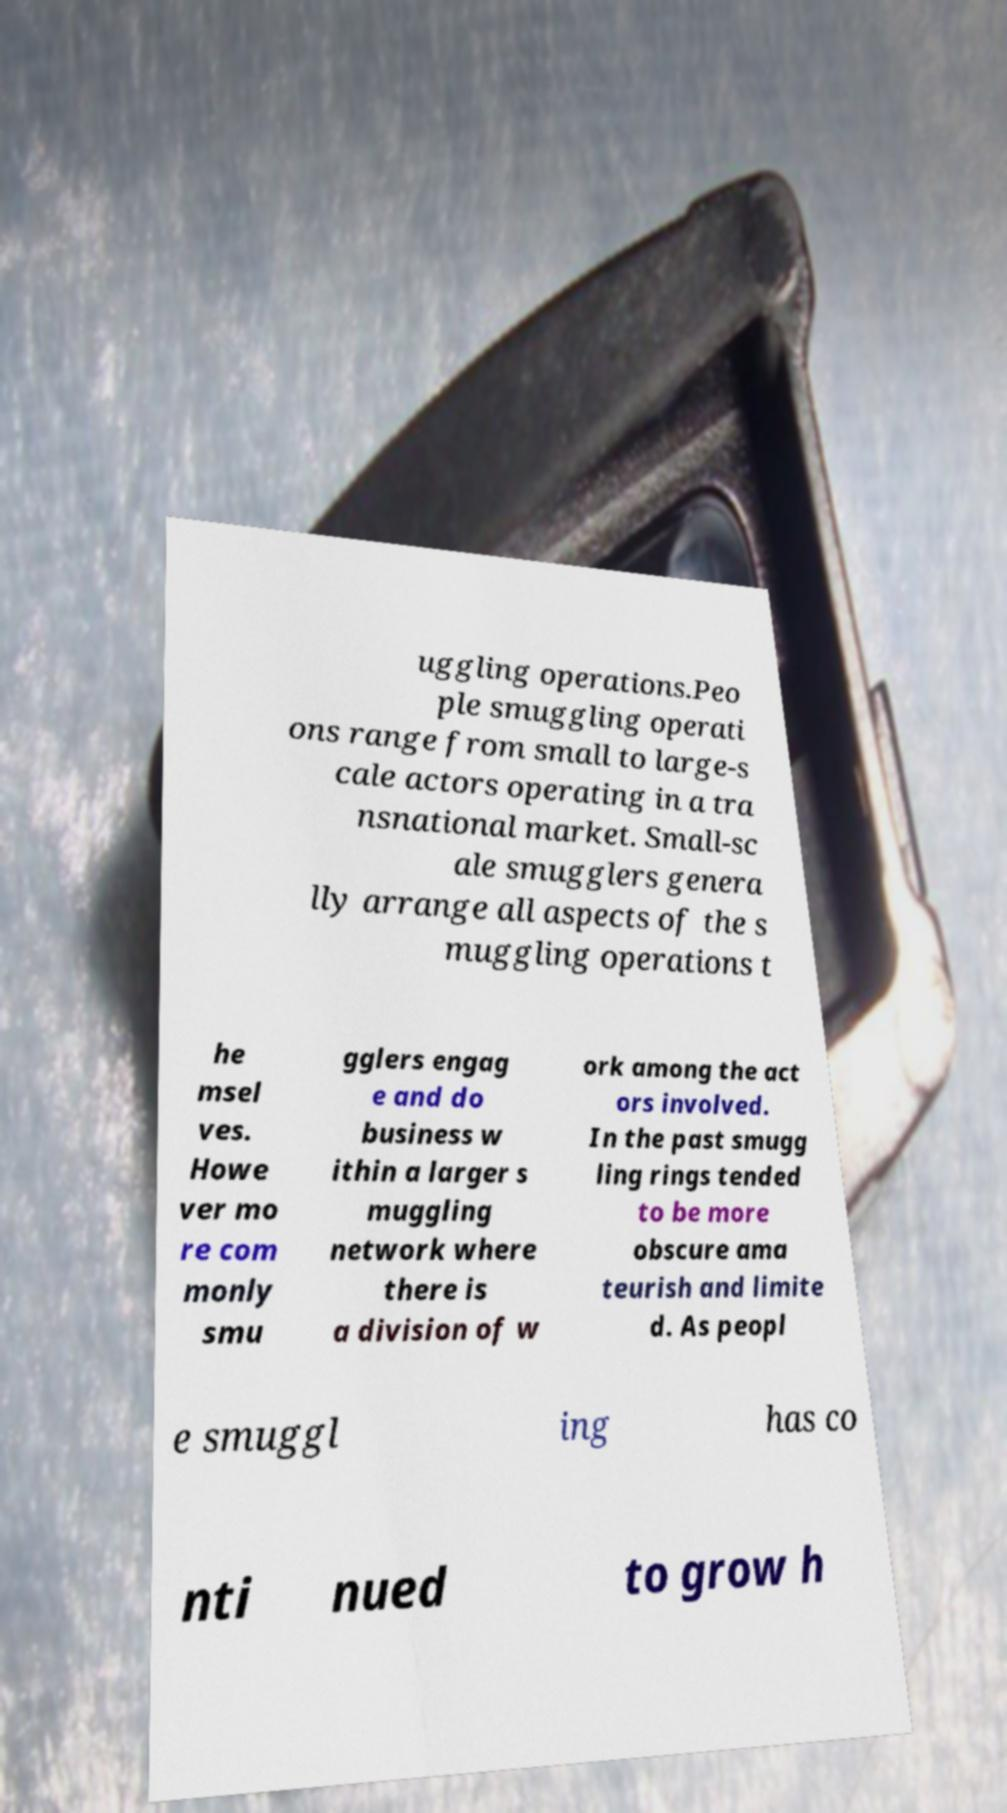Could you extract and type out the text from this image? uggling operations.Peo ple smuggling operati ons range from small to large-s cale actors operating in a tra nsnational market. Small-sc ale smugglers genera lly arrange all aspects of the s muggling operations t he msel ves. Howe ver mo re com monly smu gglers engag e and do business w ithin a larger s muggling network where there is a division of w ork among the act ors involved. In the past smugg ling rings tended to be more obscure ama teurish and limite d. As peopl e smuggl ing has co nti nued to grow h 